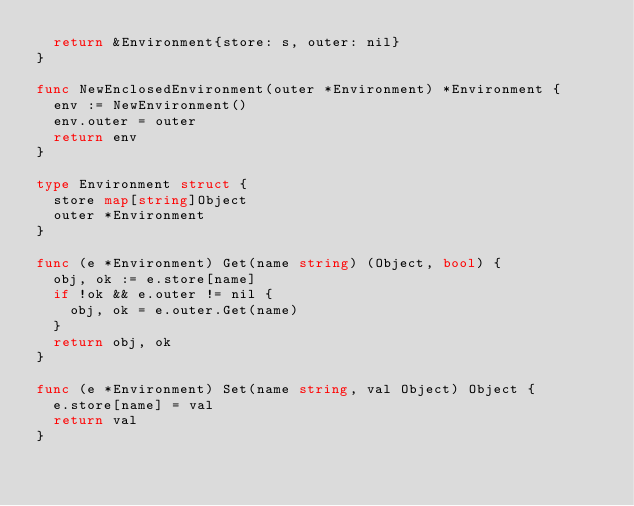<code> <loc_0><loc_0><loc_500><loc_500><_Go_>	return &Environment{store: s, outer: nil}
}

func NewEnclosedEnvironment(outer *Environment) *Environment {
	env := NewEnvironment()
	env.outer = outer
	return env
}

type Environment struct {
	store map[string]Object
	outer *Environment
}

func (e *Environment) Get(name string) (Object, bool) {
	obj, ok := e.store[name]
	if !ok && e.outer != nil {
		obj, ok = e.outer.Get(name)
	}
	return obj, ok
}

func (e *Environment) Set(name string, val Object) Object {
	e.store[name] = val
	return val
}
</code> 